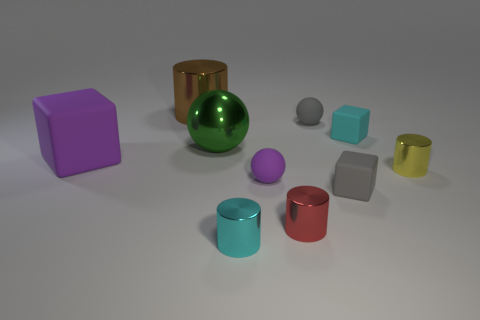How many other objects are the same material as the cyan cube?
Your answer should be compact. 4. There is a cyan cylinder that is the same size as the gray matte sphere; what is its material?
Keep it short and to the point. Metal. Does the cyan metal cylinder have the same size as the purple thing on the left side of the large shiny ball?
Make the answer very short. No. What number of rubber things are either brown cylinders or yellow objects?
Ensure brevity in your answer.  0. How many other shiny things are the same shape as the big brown object?
Ensure brevity in your answer.  3. There is a ball that is the same color as the big matte block; what is its material?
Make the answer very short. Rubber. Is the size of the block that is on the left side of the large brown metal thing the same as the gray matte object behind the large green metallic thing?
Your response must be concise. No. What shape is the cyan object behind the gray matte block?
Give a very brief answer. Cube. What is the material of the cyan object that is the same shape as the big purple rubber thing?
Provide a succinct answer. Rubber. There is a metallic thing that is behind the green shiny ball; is it the same size as the large green object?
Make the answer very short. Yes. 